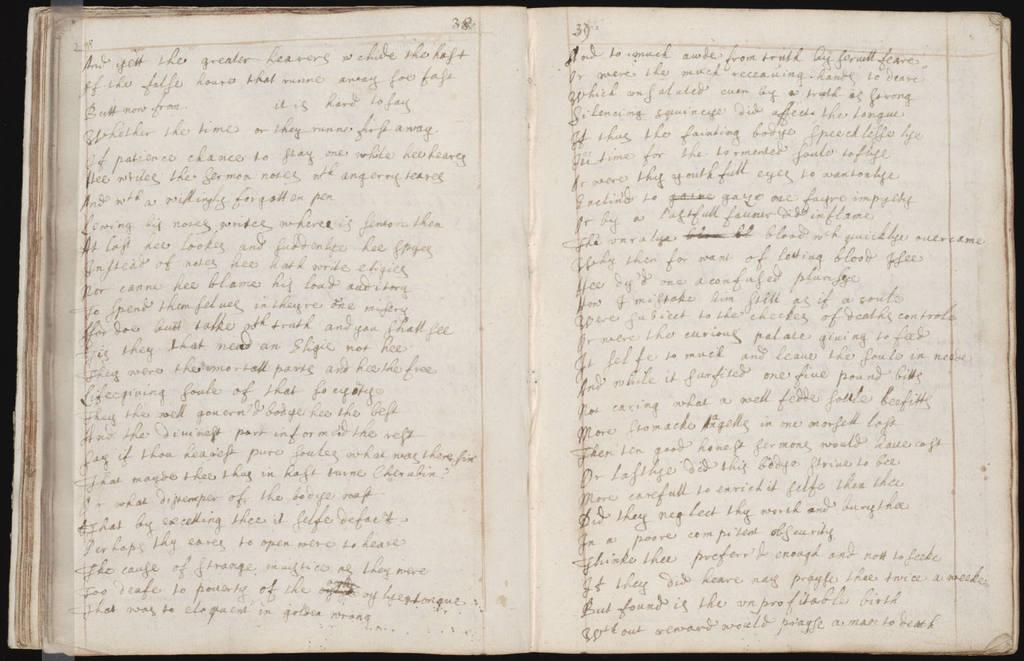<image>
Share a concise interpretation of the image provided. The first word on the page of an open book is and. 